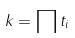Convert formula to latex. <formula><loc_0><loc_0><loc_500><loc_500>k = \prod t _ { i }</formula> 